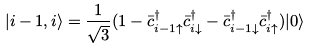<formula> <loc_0><loc_0><loc_500><loc_500>| i - 1 , i \rangle = \frac { 1 } { \sqrt { 3 } } ( 1 - { \bar { c } } ^ { \dagger } _ { i - 1 \uparrow } { \bar { c } } ^ { \dagger } _ { i \downarrow } - { \bar { c } } ^ { \dagger } _ { i - 1 \downarrow } { \bar { c } } ^ { \dagger } _ { i \uparrow } ) | 0 \rangle</formula> 